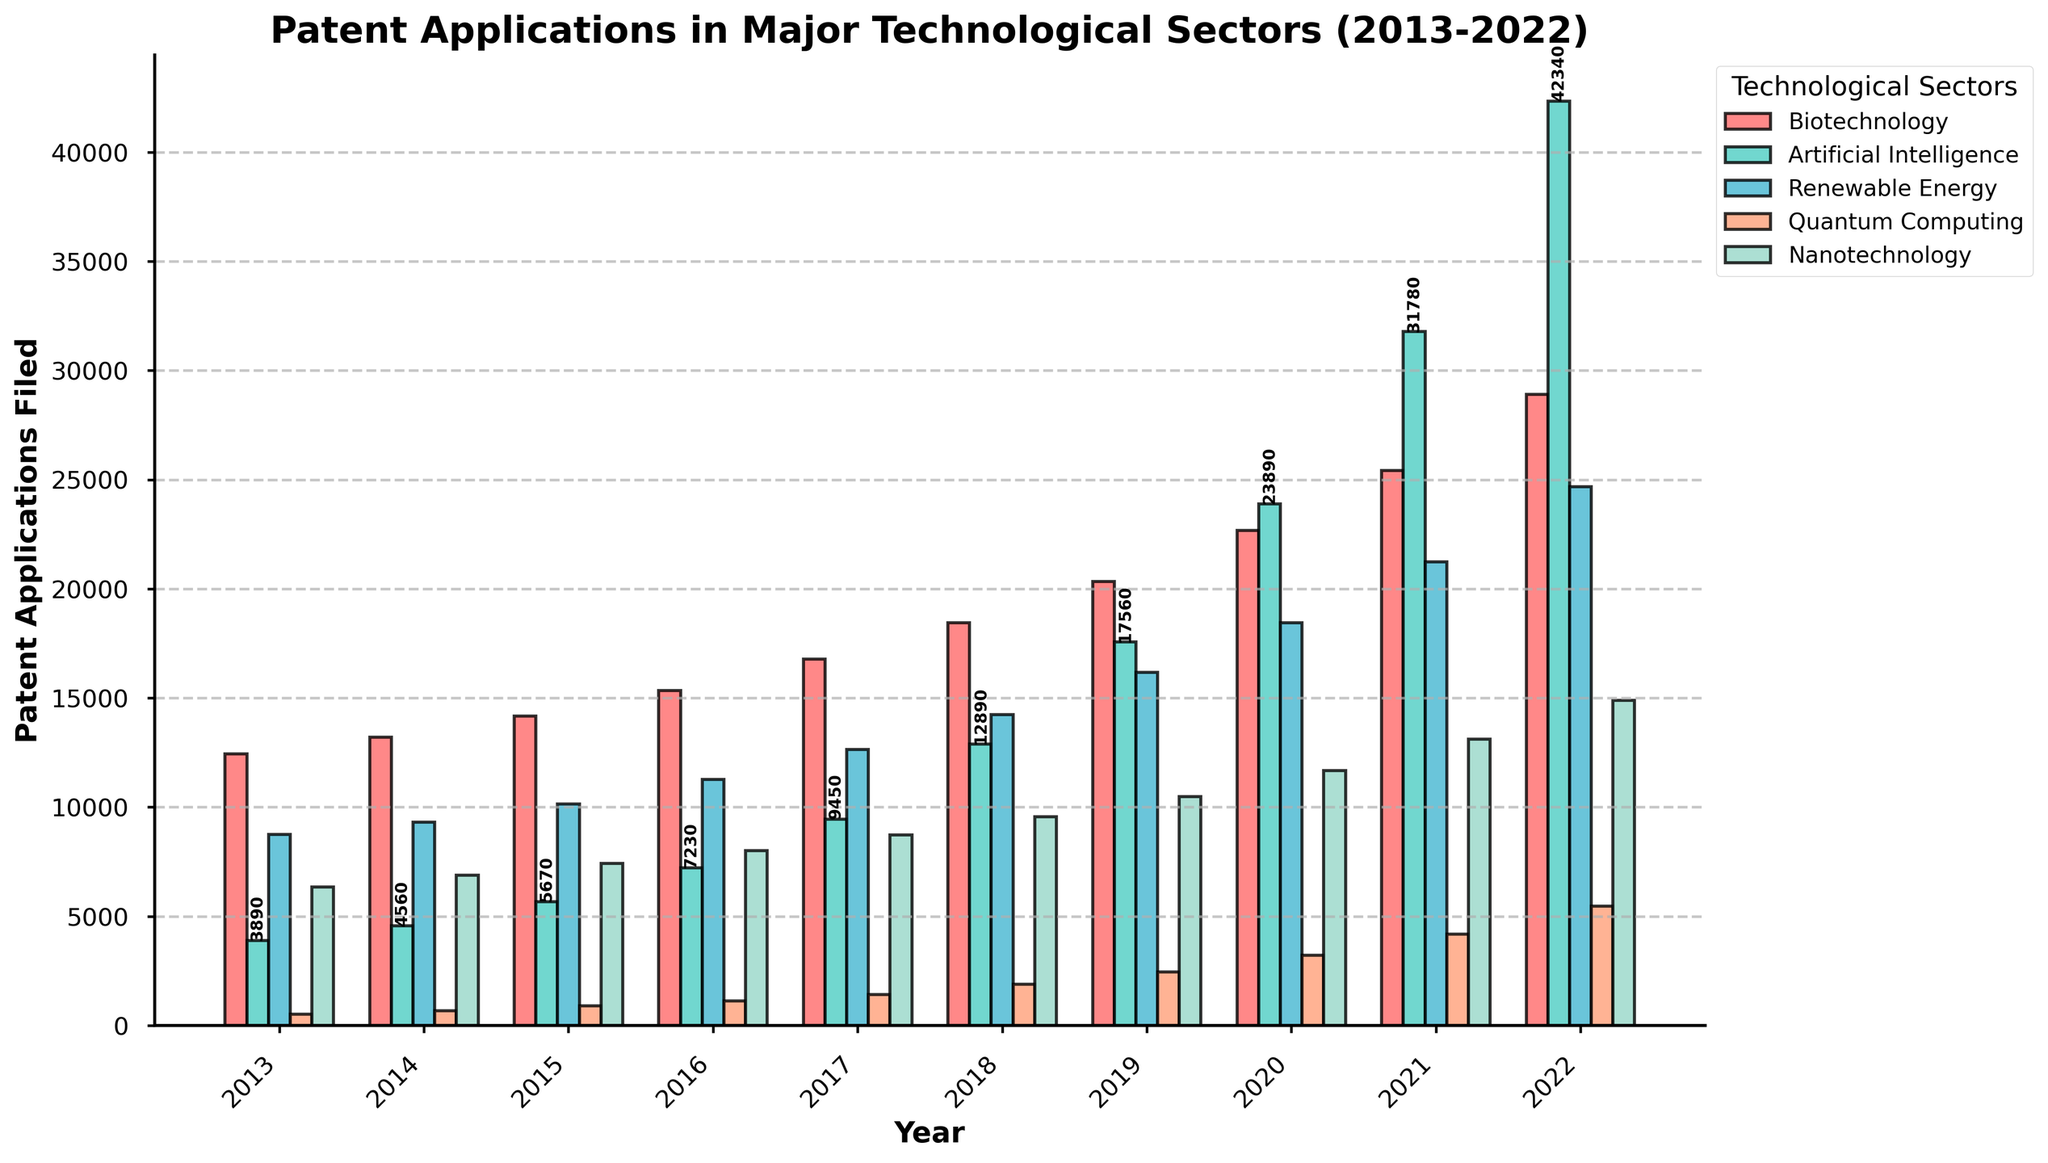What is the total number of patent applications filed across all technological sectors in 2022? To find the total, sum up the patent applications for each sector in 2022: Biotechnology (28910) + Artificial Intelligence (42340) + Renewable Energy (24680) + Quantum Computing (5460) + Nanotechnology (14890) = 116280
Answer: 116280 Which technological sector had the highest number of patent applications in 2020? Compare the patent applications for each sector in 2020; Biotechnology (22680), Artificial Intelligence (23890), Renewable Energy (18450), Quantum Computing (3210), Nanotechnology (11670). Artificial Intelligence has the highest number.
Answer: Artificial Intelligence How did the number of Quantum Computing patent applications change from 2013 to 2022? Subtract the number of patent applications in 2013 (520) from the number in 2022 (5460): 5460 - 520 = 4940
Answer: 4940 In what year did Renewable Energy patent applications surpass 20000 for the first time? Review the data for Renewable Energy: 21230 in 2021 is the first year it surpassed 20000.
Answer: 2021 Between which two consecutive years did Biotechnology patent applications show the largest increase? Calculate the differences between consecutive years: 2014-2013 (13210-12450=760), 2015-2014 (14180-13210=970), 2016-2015 (15340-14180=1160), 2017-2016 (16780-15340=1440), 2018-2017 (18450-16780=1670), 2019-2018 (20340-18450=1890), 2020-2019 (22680-20340=2340), 2021-2020 (25430-22680=2750), 2022-2021 (28910-25430=3480). The largest increase is from 2021-2022.
Answer: 2021-2022 What was the average number of Artificial Intelligence patent applications filed per year over the decade? Sum the applications from each year: 3890 + 4560 + 5670 + 7230 + 9450 + 12890 + 17560 + 23890 + 31780 + 42340 = 159260. Divide by 10 years: 159260 / 10 = 15926
Answer: 15926 Which year showed the highest total number of patent applications across all sectors? Sum the patent applications for each year and compare:
2013: 12450+3890+8760+520+6340=31960;
2014: 13210+4560+9320+680+6890=34660;
2015: 14180+5670+10150+890+7420=38310;
2016: 15340+7230+11280+1130+8010=42990;
2017: 16780+9450+12640+1420+8730=49020;
2018: 18450+12890+14230+1890+9560=57020;
2019: 20340+17560+16180+2460+10480=67020;
2020: 22680+23890+18450+3210+11670=79900;
2021: 25430+31780+21230+4180+13120=95740;
2022: 28910+42340+24680+5460+14890=116280. The highest total is in 2022.
Answer: 2022 Which technological sector had the least growth in patent applications from 2013 to 2022? Calculate the growth for each sector: 
Biotechnology: 28910-12450=16460;
Artificial Intelligence: 42340-3890=38450;
Renewable Energy: 24680-8760=15920;
Quantum Computing: 5460-520=4940;
Nanotechnology: 14890-6340=8550. The least growth is in Quantum Computing.
Answer: Quantum Computing 